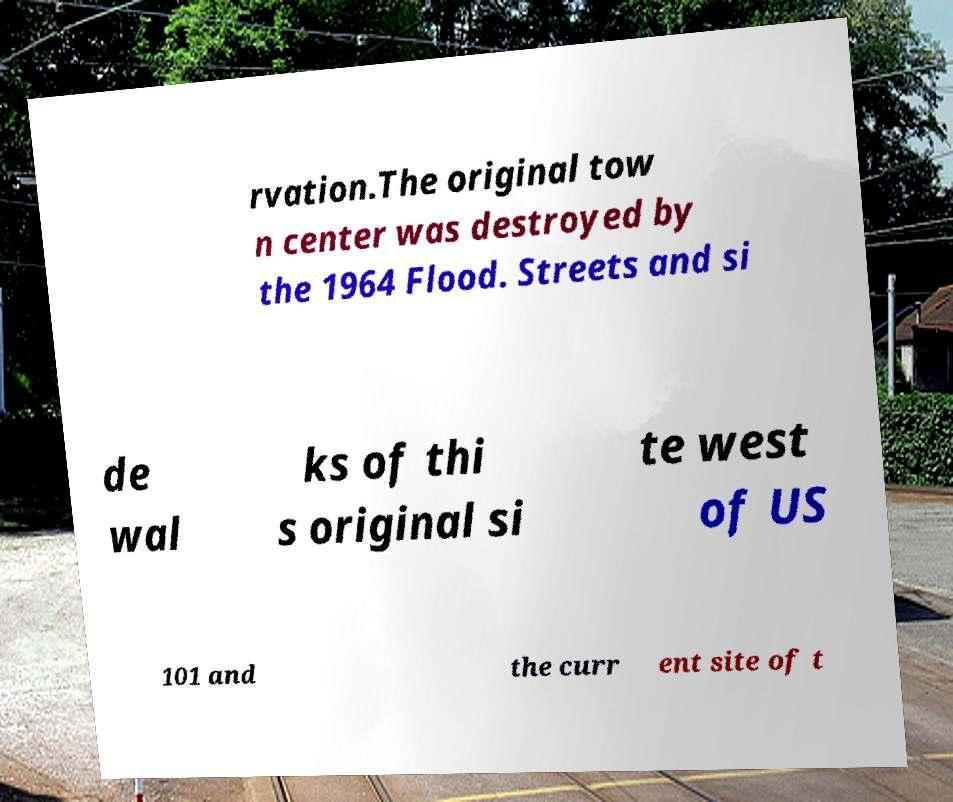Can you read and provide the text displayed in the image?This photo seems to have some interesting text. Can you extract and type it out for me? rvation.The original tow n center was destroyed by the 1964 Flood. Streets and si de wal ks of thi s original si te west of US 101 and the curr ent site of t 